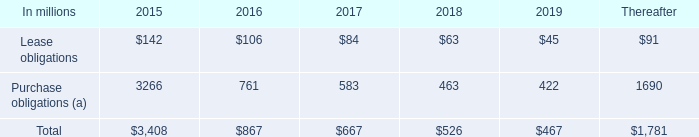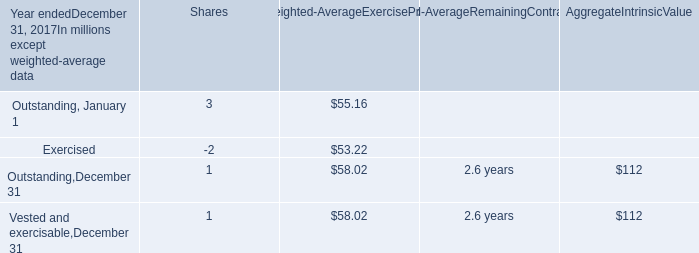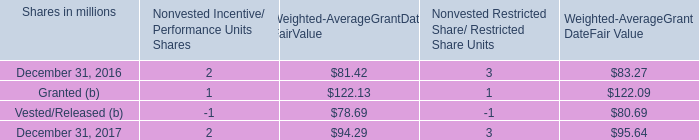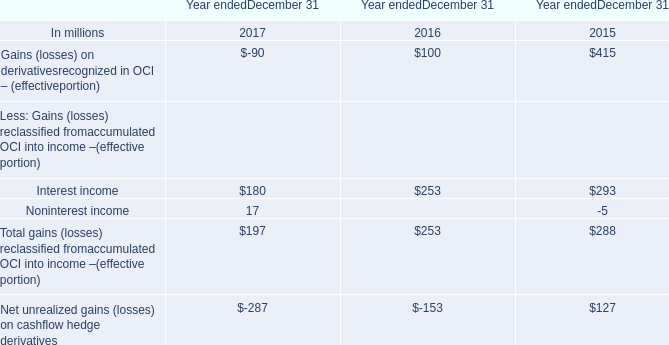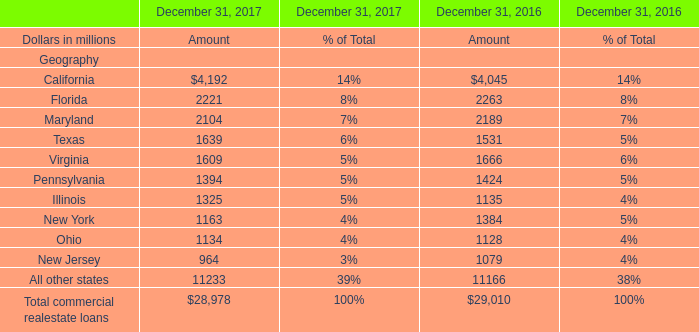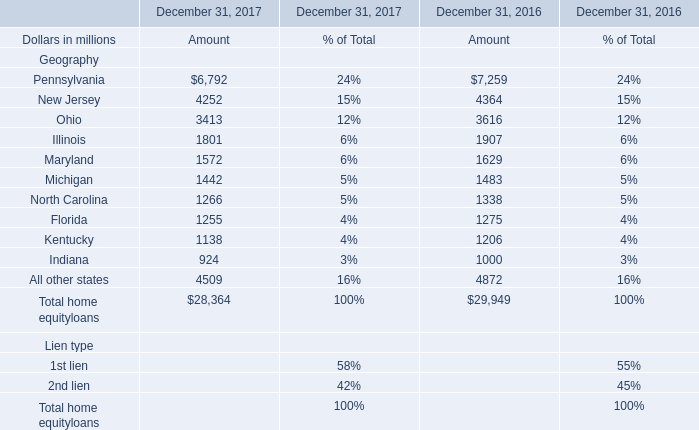What is the average amount of Virginia of December 31, 2016 Amount, and New Jersey of December 31, 2017 Amount ? 
Computations: ((1666.0 + 4252.0) / 2)
Answer: 2959.0. 